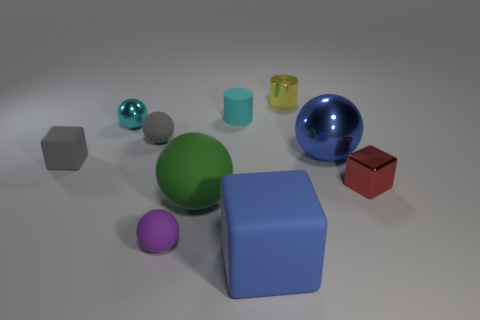Subtract 1 balls. How many balls are left? 4 Subtract all green spheres. How many spheres are left? 4 Subtract all small shiny balls. How many balls are left? 4 Subtract all red spheres. Subtract all purple cylinders. How many spheres are left? 5 Subtract all blocks. How many objects are left? 7 Subtract all blue things. Subtract all matte balls. How many objects are left? 5 Add 1 cyan cylinders. How many cyan cylinders are left? 2 Add 2 large red rubber things. How many large red rubber things exist? 2 Subtract 0 green blocks. How many objects are left? 10 